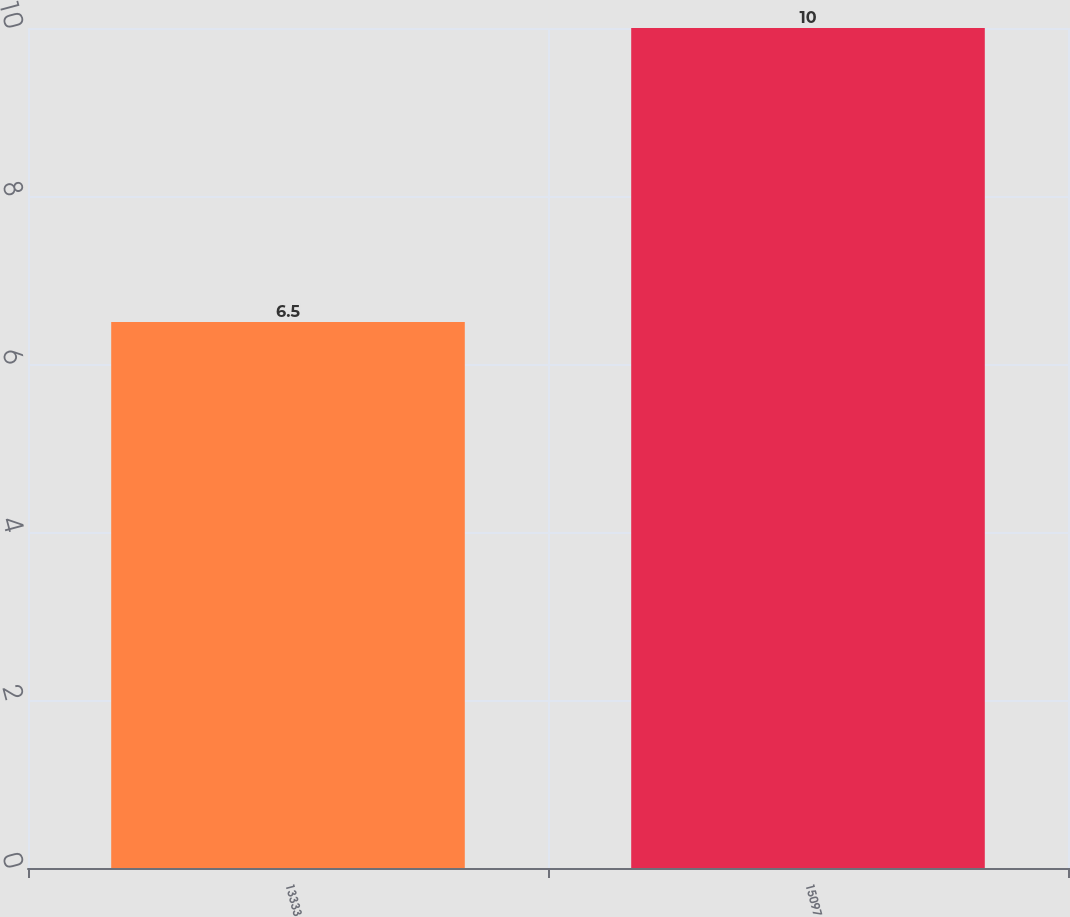Convert chart. <chart><loc_0><loc_0><loc_500><loc_500><bar_chart><fcel>13333<fcel>15097<nl><fcel>6.5<fcel>10<nl></chart> 